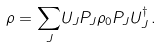<formula> <loc_0><loc_0><loc_500><loc_500>\rho = { \sum _ { J } } U _ { J } P _ { J } \rho _ { 0 } P _ { J } U _ { J } ^ { \dagger } \, .</formula> 